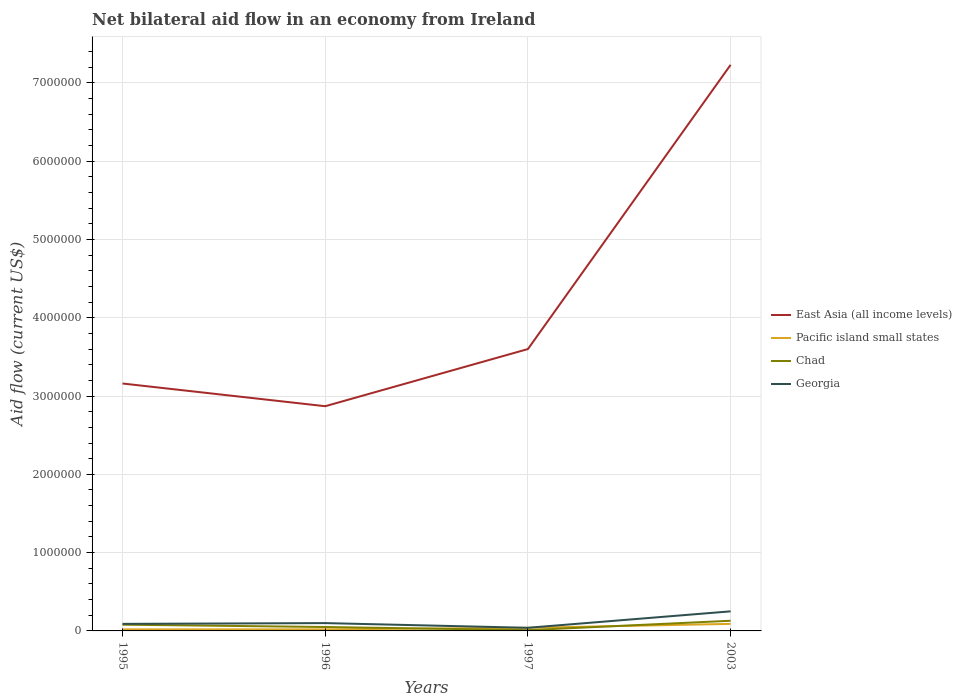How many different coloured lines are there?
Keep it short and to the point. 4. Across all years, what is the maximum net bilateral aid flow in East Asia (all income levels)?
Make the answer very short. 2.87e+06. In which year was the net bilateral aid flow in Georgia maximum?
Provide a short and direct response. 1997. What is the difference between the highest and the lowest net bilateral aid flow in Pacific island small states?
Ensure brevity in your answer.  1. Is the net bilateral aid flow in Georgia strictly greater than the net bilateral aid flow in Chad over the years?
Give a very brief answer. No. How many lines are there?
Your answer should be very brief. 4. What is the difference between two consecutive major ticks on the Y-axis?
Give a very brief answer. 1.00e+06. Does the graph contain any zero values?
Give a very brief answer. No. Does the graph contain grids?
Your response must be concise. Yes. Where does the legend appear in the graph?
Your answer should be very brief. Center right. How many legend labels are there?
Give a very brief answer. 4. What is the title of the graph?
Make the answer very short. Net bilateral aid flow in an economy from Ireland. What is the label or title of the X-axis?
Provide a short and direct response. Years. What is the Aid flow (current US$) of East Asia (all income levels) in 1995?
Your answer should be compact. 3.16e+06. What is the Aid flow (current US$) of East Asia (all income levels) in 1996?
Provide a short and direct response. 2.87e+06. What is the Aid flow (current US$) of Georgia in 1996?
Give a very brief answer. 1.00e+05. What is the Aid flow (current US$) of East Asia (all income levels) in 1997?
Offer a terse response. 3.60e+06. What is the Aid flow (current US$) of East Asia (all income levels) in 2003?
Give a very brief answer. 7.23e+06. What is the Aid flow (current US$) of Pacific island small states in 2003?
Keep it short and to the point. 9.00e+04. What is the Aid flow (current US$) in Chad in 2003?
Keep it short and to the point. 1.30e+05. What is the Aid flow (current US$) of Georgia in 2003?
Offer a very short reply. 2.50e+05. Across all years, what is the maximum Aid flow (current US$) in East Asia (all income levels)?
Provide a short and direct response. 7.23e+06. Across all years, what is the minimum Aid flow (current US$) in East Asia (all income levels)?
Your response must be concise. 2.87e+06. Across all years, what is the minimum Aid flow (current US$) in Pacific island small states?
Give a very brief answer. 2.00e+04. What is the total Aid flow (current US$) of East Asia (all income levels) in the graph?
Ensure brevity in your answer.  1.69e+07. What is the total Aid flow (current US$) of Chad in the graph?
Offer a terse response. 2.70e+05. What is the difference between the Aid flow (current US$) in East Asia (all income levels) in 1995 and that in 1997?
Keep it short and to the point. -4.40e+05. What is the difference between the Aid flow (current US$) in Georgia in 1995 and that in 1997?
Provide a succinct answer. 5.00e+04. What is the difference between the Aid flow (current US$) of East Asia (all income levels) in 1995 and that in 2003?
Offer a terse response. -4.07e+06. What is the difference between the Aid flow (current US$) in East Asia (all income levels) in 1996 and that in 1997?
Your answer should be very brief. -7.30e+05. What is the difference between the Aid flow (current US$) in Chad in 1996 and that in 1997?
Ensure brevity in your answer.  4.00e+04. What is the difference between the Aid flow (current US$) of Georgia in 1996 and that in 1997?
Provide a short and direct response. 6.00e+04. What is the difference between the Aid flow (current US$) of East Asia (all income levels) in 1996 and that in 2003?
Provide a short and direct response. -4.36e+06. What is the difference between the Aid flow (current US$) of Pacific island small states in 1996 and that in 2003?
Provide a short and direct response. -7.00e+04. What is the difference between the Aid flow (current US$) in Chad in 1996 and that in 2003?
Provide a succinct answer. -8.00e+04. What is the difference between the Aid flow (current US$) of East Asia (all income levels) in 1997 and that in 2003?
Your answer should be compact. -3.63e+06. What is the difference between the Aid flow (current US$) in Chad in 1997 and that in 2003?
Offer a very short reply. -1.20e+05. What is the difference between the Aid flow (current US$) of Georgia in 1997 and that in 2003?
Provide a short and direct response. -2.10e+05. What is the difference between the Aid flow (current US$) in East Asia (all income levels) in 1995 and the Aid flow (current US$) in Pacific island small states in 1996?
Ensure brevity in your answer.  3.14e+06. What is the difference between the Aid flow (current US$) in East Asia (all income levels) in 1995 and the Aid flow (current US$) in Chad in 1996?
Your response must be concise. 3.11e+06. What is the difference between the Aid flow (current US$) of East Asia (all income levels) in 1995 and the Aid flow (current US$) of Georgia in 1996?
Offer a terse response. 3.06e+06. What is the difference between the Aid flow (current US$) of Pacific island small states in 1995 and the Aid flow (current US$) of Georgia in 1996?
Make the answer very short. -8.00e+04. What is the difference between the Aid flow (current US$) of Chad in 1995 and the Aid flow (current US$) of Georgia in 1996?
Your answer should be compact. -2.00e+04. What is the difference between the Aid flow (current US$) of East Asia (all income levels) in 1995 and the Aid flow (current US$) of Pacific island small states in 1997?
Your answer should be compact. 3.12e+06. What is the difference between the Aid flow (current US$) in East Asia (all income levels) in 1995 and the Aid flow (current US$) in Chad in 1997?
Offer a very short reply. 3.15e+06. What is the difference between the Aid flow (current US$) in East Asia (all income levels) in 1995 and the Aid flow (current US$) in Georgia in 1997?
Keep it short and to the point. 3.12e+06. What is the difference between the Aid flow (current US$) in Pacific island small states in 1995 and the Aid flow (current US$) in Georgia in 1997?
Your response must be concise. -2.00e+04. What is the difference between the Aid flow (current US$) in East Asia (all income levels) in 1995 and the Aid flow (current US$) in Pacific island small states in 2003?
Give a very brief answer. 3.07e+06. What is the difference between the Aid flow (current US$) of East Asia (all income levels) in 1995 and the Aid flow (current US$) of Chad in 2003?
Your response must be concise. 3.03e+06. What is the difference between the Aid flow (current US$) in East Asia (all income levels) in 1995 and the Aid flow (current US$) in Georgia in 2003?
Offer a very short reply. 2.91e+06. What is the difference between the Aid flow (current US$) in Pacific island small states in 1995 and the Aid flow (current US$) in Georgia in 2003?
Provide a short and direct response. -2.30e+05. What is the difference between the Aid flow (current US$) in East Asia (all income levels) in 1996 and the Aid flow (current US$) in Pacific island small states in 1997?
Your answer should be very brief. 2.83e+06. What is the difference between the Aid flow (current US$) in East Asia (all income levels) in 1996 and the Aid flow (current US$) in Chad in 1997?
Your response must be concise. 2.86e+06. What is the difference between the Aid flow (current US$) of East Asia (all income levels) in 1996 and the Aid flow (current US$) of Georgia in 1997?
Provide a succinct answer. 2.83e+06. What is the difference between the Aid flow (current US$) in East Asia (all income levels) in 1996 and the Aid flow (current US$) in Pacific island small states in 2003?
Your response must be concise. 2.78e+06. What is the difference between the Aid flow (current US$) in East Asia (all income levels) in 1996 and the Aid flow (current US$) in Chad in 2003?
Make the answer very short. 2.74e+06. What is the difference between the Aid flow (current US$) in East Asia (all income levels) in 1996 and the Aid flow (current US$) in Georgia in 2003?
Provide a short and direct response. 2.62e+06. What is the difference between the Aid flow (current US$) of Pacific island small states in 1996 and the Aid flow (current US$) of Georgia in 2003?
Offer a terse response. -2.30e+05. What is the difference between the Aid flow (current US$) in East Asia (all income levels) in 1997 and the Aid flow (current US$) in Pacific island small states in 2003?
Keep it short and to the point. 3.51e+06. What is the difference between the Aid flow (current US$) of East Asia (all income levels) in 1997 and the Aid flow (current US$) of Chad in 2003?
Make the answer very short. 3.47e+06. What is the difference between the Aid flow (current US$) of East Asia (all income levels) in 1997 and the Aid flow (current US$) of Georgia in 2003?
Offer a terse response. 3.35e+06. What is the difference between the Aid flow (current US$) in Pacific island small states in 1997 and the Aid flow (current US$) in Chad in 2003?
Your answer should be compact. -9.00e+04. What is the average Aid flow (current US$) in East Asia (all income levels) per year?
Your answer should be very brief. 4.22e+06. What is the average Aid flow (current US$) of Pacific island small states per year?
Give a very brief answer. 4.25e+04. What is the average Aid flow (current US$) in Chad per year?
Keep it short and to the point. 6.75e+04. In the year 1995, what is the difference between the Aid flow (current US$) in East Asia (all income levels) and Aid flow (current US$) in Pacific island small states?
Offer a very short reply. 3.14e+06. In the year 1995, what is the difference between the Aid flow (current US$) of East Asia (all income levels) and Aid flow (current US$) of Chad?
Ensure brevity in your answer.  3.08e+06. In the year 1995, what is the difference between the Aid flow (current US$) in East Asia (all income levels) and Aid flow (current US$) in Georgia?
Keep it short and to the point. 3.07e+06. In the year 1995, what is the difference between the Aid flow (current US$) in Pacific island small states and Aid flow (current US$) in Georgia?
Offer a very short reply. -7.00e+04. In the year 1996, what is the difference between the Aid flow (current US$) in East Asia (all income levels) and Aid flow (current US$) in Pacific island small states?
Offer a very short reply. 2.85e+06. In the year 1996, what is the difference between the Aid flow (current US$) in East Asia (all income levels) and Aid flow (current US$) in Chad?
Offer a very short reply. 2.82e+06. In the year 1996, what is the difference between the Aid flow (current US$) of East Asia (all income levels) and Aid flow (current US$) of Georgia?
Your answer should be compact. 2.77e+06. In the year 1996, what is the difference between the Aid flow (current US$) in Pacific island small states and Aid flow (current US$) in Chad?
Offer a terse response. -3.00e+04. In the year 1996, what is the difference between the Aid flow (current US$) of Pacific island small states and Aid flow (current US$) of Georgia?
Your answer should be very brief. -8.00e+04. In the year 1997, what is the difference between the Aid flow (current US$) in East Asia (all income levels) and Aid flow (current US$) in Pacific island small states?
Your answer should be compact. 3.56e+06. In the year 1997, what is the difference between the Aid flow (current US$) in East Asia (all income levels) and Aid flow (current US$) in Chad?
Provide a short and direct response. 3.59e+06. In the year 1997, what is the difference between the Aid flow (current US$) of East Asia (all income levels) and Aid flow (current US$) of Georgia?
Offer a terse response. 3.56e+06. In the year 1997, what is the difference between the Aid flow (current US$) of Pacific island small states and Aid flow (current US$) of Chad?
Provide a short and direct response. 3.00e+04. In the year 1997, what is the difference between the Aid flow (current US$) of Pacific island small states and Aid flow (current US$) of Georgia?
Make the answer very short. 0. In the year 1997, what is the difference between the Aid flow (current US$) in Chad and Aid flow (current US$) in Georgia?
Provide a short and direct response. -3.00e+04. In the year 2003, what is the difference between the Aid flow (current US$) in East Asia (all income levels) and Aid flow (current US$) in Pacific island small states?
Offer a terse response. 7.14e+06. In the year 2003, what is the difference between the Aid flow (current US$) of East Asia (all income levels) and Aid flow (current US$) of Chad?
Make the answer very short. 7.10e+06. In the year 2003, what is the difference between the Aid flow (current US$) of East Asia (all income levels) and Aid flow (current US$) of Georgia?
Your response must be concise. 6.98e+06. In the year 2003, what is the difference between the Aid flow (current US$) of Pacific island small states and Aid flow (current US$) of Chad?
Ensure brevity in your answer.  -4.00e+04. In the year 2003, what is the difference between the Aid flow (current US$) in Pacific island small states and Aid flow (current US$) in Georgia?
Offer a terse response. -1.60e+05. What is the ratio of the Aid flow (current US$) of East Asia (all income levels) in 1995 to that in 1996?
Your answer should be compact. 1.1. What is the ratio of the Aid flow (current US$) of Georgia in 1995 to that in 1996?
Make the answer very short. 0.9. What is the ratio of the Aid flow (current US$) in East Asia (all income levels) in 1995 to that in 1997?
Provide a short and direct response. 0.88. What is the ratio of the Aid flow (current US$) of Georgia in 1995 to that in 1997?
Provide a short and direct response. 2.25. What is the ratio of the Aid flow (current US$) of East Asia (all income levels) in 1995 to that in 2003?
Make the answer very short. 0.44. What is the ratio of the Aid flow (current US$) in Pacific island small states in 1995 to that in 2003?
Ensure brevity in your answer.  0.22. What is the ratio of the Aid flow (current US$) in Chad in 1995 to that in 2003?
Give a very brief answer. 0.62. What is the ratio of the Aid flow (current US$) in Georgia in 1995 to that in 2003?
Make the answer very short. 0.36. What is the ratio of the Aid flow (current US$) of East Asia (all income levels) in 1996 to that in 1997?
Offer a terse response. 0.8. What is the ratio of the Aid flow (current US$) in Pacific island small states in 1996 to that in 1997?
Provide a short and direct response. 0.5. What is the ratio of the Aid flow (current US$) of East Asia (all income levels) in 1996 to that in 2003?
Offer a terse response. 0.4. What is the ratio of the Aid flow (current US$) of Pacific island small states in 1996 to that in 2003?
Offer a very short reply. 0.22. What is the ratio of the Aid flow (current US$) in Chad in 1996 to that in 2003?
Offer a very short reply. 0.38. What is the ratio of the Aid flow (current US$) in East Asia (all income levels) in 1997 to that in 2003?
Make the answer very short. 0.5. What is the ratio of the Aid flow (current US$) of Pacific island small states in 1997 to that in 2003?
Provide a short and direct response. 0.44. What is the ratio of the Aid flow (current US$) of Chad in 1997 to that in 2003?
Ensure brevity in your answer.  0.08. What is the ratio of the Aid flow (current US$) of Georgia in 1997 to that in 2003?
Keep it short and to the point. 0.16. What is the difference between the highest and the second highest Aid flow (current US$) of East Asia (all income levels)?
Provide a succinct answer. 3.63e+06. What is the difference between the highest and the second highest Aid flow (current US$) of Georgia?
Provide a succinct answer. 1.50e+05. What is the difference between the highest and the lowest Aid flow (current US$) in East Asia (all income levels)?
Your answer should be very brief. 4.36e+06. What is the difference between the highest and the lowest Aid flow (current US$) in Pacific island small states?
Ensure brevity in your answer.  7.00e+04. 